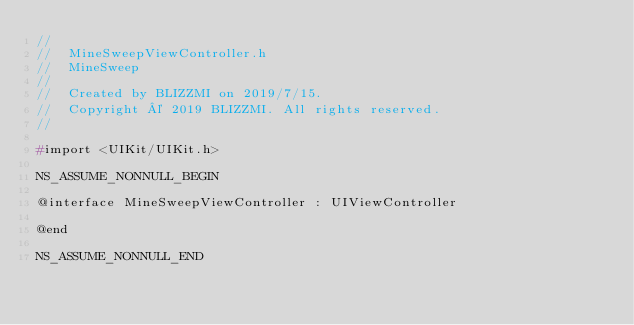Convert code to text. <code><loc_0><loc_0><loc_500><loc_500><_C_>//
//  MineSweepViewController.h
//  MineSweep
//
//  Created by BLIZZMI on 2019/7/15.
//  Copyright © 2019 BLIZZMI. All rights reserved.
//

#import <UIKit/UIKit.h>

NS_ASSUME_NONNULL_BEGIN

@interface MineSweepViewController : UIViewController

@end

NS_ASSUME_NONNULL_END
</code> 